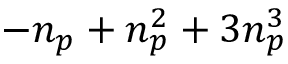Convert formula to latex. <formula><loc_0><loc_0><loc_500><loc_500>- { n _ { p } } + { n _ { p } } ^ { 2 } + 3 { n _ { p } } ^ { 3 }</formula> 